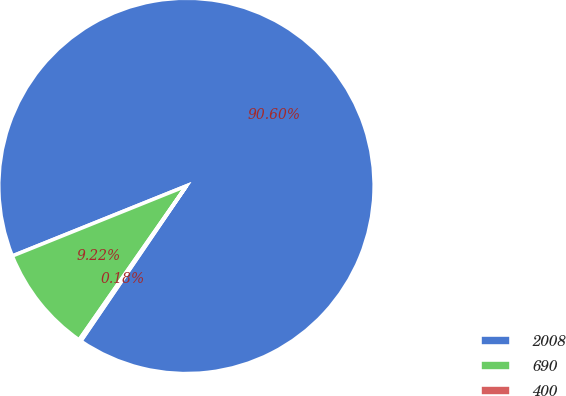Convert chart. <chart><loc_0><loc_0><loc_500><loc_500><pie_chart><fcel>2008<fcel>690<fcel>400<nl><fcel>90.6%<fcel>9.22%<fcel>0.18%<nl></chart> 